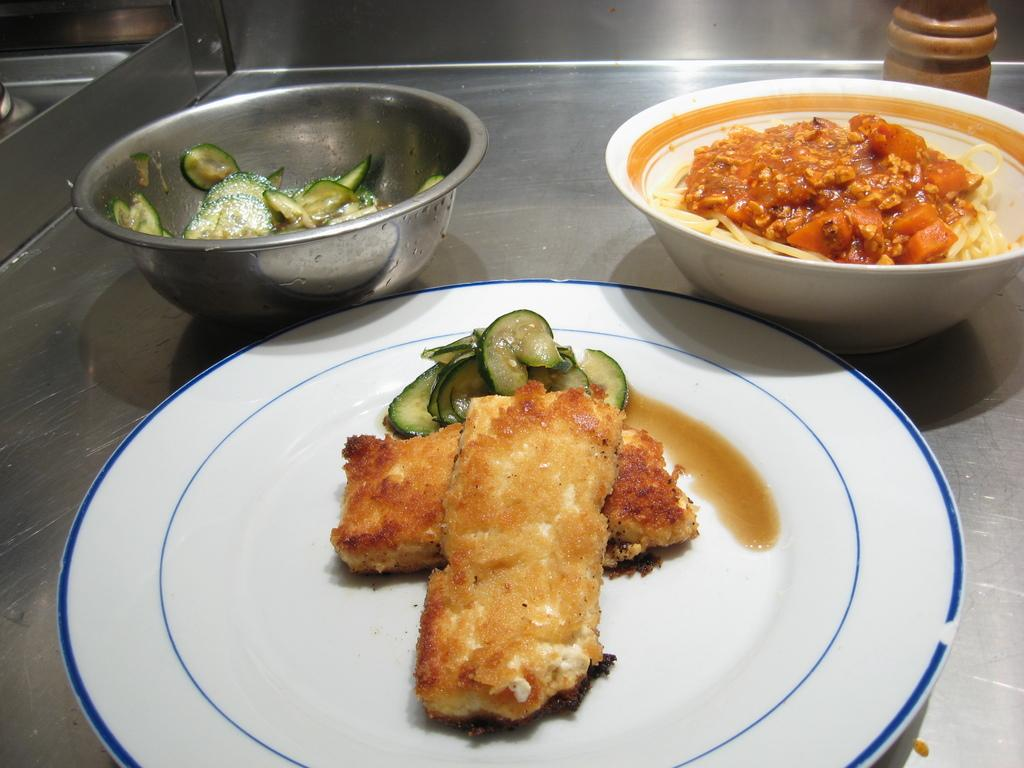What is the main subject in the center of the image? There is an object in the center of the image. What is placed on the object? There is a plate and bowls on the object. What can be found on the plate and in the bowls? There are food items on the object. Are there any other items on the object? Yes, there are other objects on the object. Can you see the mother preparing food in the image? There is no mother or any indication of food preparation in the image. Are there any ants crawling on the food items in the image? There is no mention of ants or any other insects in the image. 